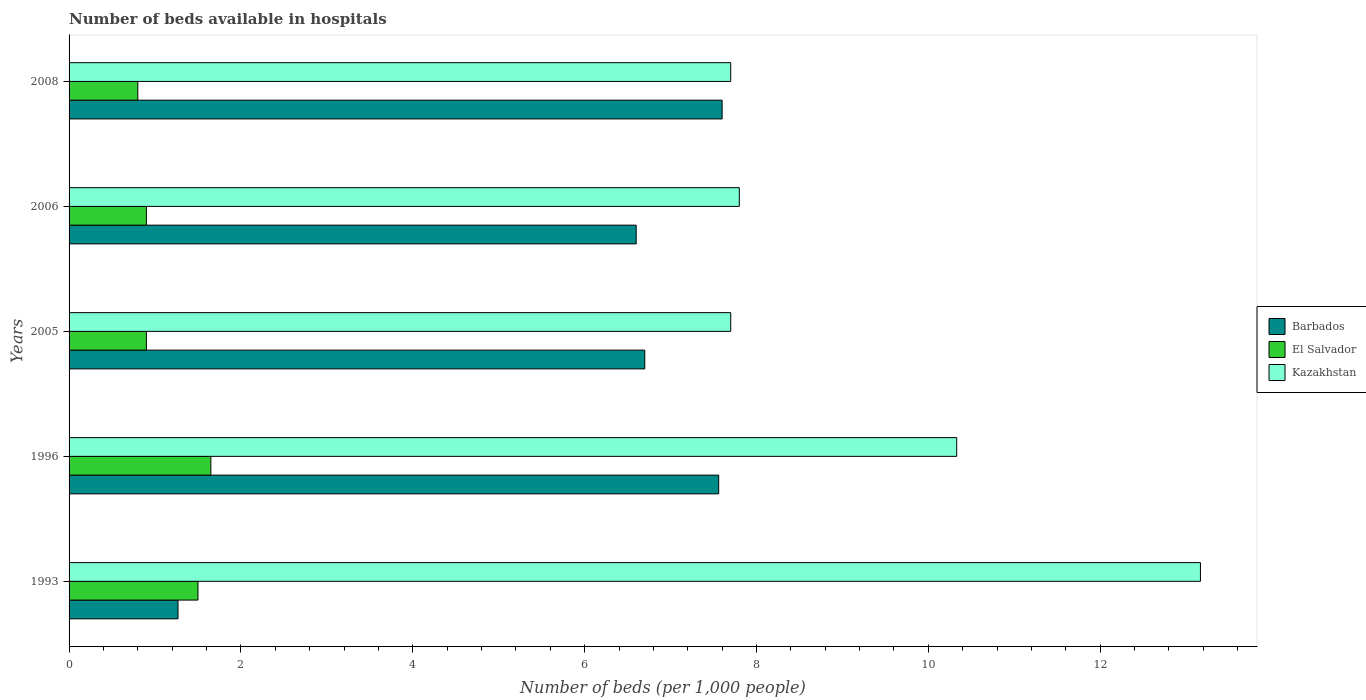How many groups of bars are there?
Give a very brief answer. 5. Are the number of bars per tick equal to the number of legend labels?
Provide a short and direct response. Yes. Are the number of bars on each tick of the Y-axis equal?
Your response must be concise. Yes. What is the label of the 3rd group of bars from the top?
Give a very brief answer. 2005. In how many cases, is the number of bars for a given year not equal to the number of legend labels?
Give a very brief answer. 0. What is the number of beds in the hospiatls of in El Salvador in 1996?
Provide a succinct answer. 1.65. Across all years, what is the maximum number of beds in the hospiatls of in Kazakhstan?
Your response must be concise. 13.17. Across all years, what is the minimum number of beds in the hospiatls of in Barbados?
Offer a very short reply. 1.27. In which year was the number of beds in the hospiatls of in Kazakhstan maximum?
Keep it short and to the point. 1993. What is the total number of beds in the hospiatls of in Kazakhstan in the graph?
Provide a succinct answer. 46.7. What is the difference between the number of beds in the hospiatls of in El Salvador in 1993 and that in 1996?
Your response must be concise. -0.15. What is the average number of beds in the hospiatls of in El Salvador per year?
Make the answer very short. 1.15. In how many years, is the number of beds in the hospiatls of in El Salvador greater than 11.6 ?
Ensure brevity in your answer.  0. What is the ratio of the number of beds in the hospiatls of in El Salvador in 2005 to that in 2006?
Your answer should be very brief. 1. What is the difference between the highest and the second highest number of beds in the hospiatls of in El Salvador?
Offer a terse response. 0.15. What is the difference between the highest and the lowest number of beds in the hospiatls of in El Salvador?
Provide a short and direct response. 0.85. What does the 2nd bar from the top in 2005 represents?
Your answer should be very brief. El Salvador. What does the 3rd bar from the bottom in 1996 represents?
Offer a very short reply. Kazakhstan. How many bars are there?
Offer a very short reply. 15. Are all the bars in the graph horizontal?
Your response must be concise. Yes. Where does the legend appear in the graph?
Your answer should be very brief. Center right. How many legend labels are there?
Your response must be concise. 3. What is the title of the graph?
Your answer should be very brief. Number of beds available in hospitals. Does "Myanmar" appear as one of the legend labels in the graph?
Offer a very short reply. No. What is the label or title of the X-axis?
Provide a short and direct response. Number of beds (per 1,0 people). What is the label or title of the Y-axis?
Offer a terse response. Years. What is the Number of beds (per 1,000 people) in Barbados in 1993?
Offer a very short reply. 1.27. What is the Number of beds (per 1,000 people) of Kazakhstan in 1993?
Offer a terse response. 13.17. What is the Number of beds (per 1,000 people) of Barbados in 1996?
Ensure brevity in your answer.  7.56. What is the Number of beds (per 1,000 people) of El Salvador in 1996?
Your answer should be very brief. 1.65. What is the Number of beds (per 1,000 people) of Kazakhstan in 1996?
Ensure brevity in your answer.  10.33. What is the Number of beds (per 1,000 people) of Barbados in 2005?
Your answer should be very brief. 6.7. What is the Number of beds (per 1,000 people) of El Salvador in 2005?
Ensure brevity in your answer.  0.9. What is the Number of beds (per 1,000 people) of El Salvador in 2006?
Your response must be concise. 0.9. What is the Number of beds (per 1,000 people) of Kazakhstan in 2006?
Your answer should be very brief. 7.8. What is the Number of beds (per 1,000 people) of Barbados in 2008?
Make the answer very short. 7.6. What is the Number of beds (per 1,000 people) of El Salvador in 2008?
Provide a succinct answer. 0.8. What is the Number of beds (per 1,000 people) of Kazakhstan in 2008?
Keep it short and to the point. 7.7. Across all years, what is the maximum Number of beds (per 1,000 people) of Barbados?
Ensure brevity in your answer.  7.6. Across all years, what is the maximum Number of beds (per 1,000 people) of El Salvador?
Give a very brief answer. 1.65. Across all years, what is the maximum Number of beds (per 1,000 people) of Kazakhstan?
Ensure brevity in your answer.  13.17. Across all years, what is the minimum Number of beds (per 1,000 people) of Barbados?
Provide a short and direct response. 1.27. Across all years, what is the minimum Number of beds (per 1,000 people) in Kazakhstan?
Your answer should be very brief. 7.7. What is the total Number of beds (per 1,000 people) in Barbados in the graph?
Provide a succinct answer. 29.73. What is the total Number of beds (per 1,000 people) of El Salvador in the graph?
Provide a short and direct response. 5.75. What is the total Number of beds (per 1,000 people) of Kazakhstan in the graph?
Offer a terse response. 46.7. What is the difference between the Number of beds (per 1,000 people) of Barbados in 1993 and that in 1996?
Your answer should be very brief. -6.29. What is the difference between the Number of beds (per 1,000 people) of El Salvador in 1993 and that in 1996?
Give a very brief answer. -0.15. What is the difference between the Number of beds (per 1,000 people) in Kazakhstan in 1993 and that in 1996?
Your response must be concise. 2.84. What is the difference between the Number of beds (per 1,000 people) of Barbados in 1993 and that in 2005?
Keep it short and to the point. -5.43. What is the difference between the Number of beds (per 1,000 people) in El Salvador in 1993 and that in 2005?
Ensure brevity in your answer.  0.6. What is the difference between the Number of beds (per 1,000 people) of Kazakhstan in 1993 and that in 2005?
Your response must be concise. 5.47. What is the difference between the Number of beds (per 1,000 people) in Barbados in 1993 and that in 2006?
Provide a succinct answer. -5.33. What is the difference between the Number of beds (per 1,000 people) of El Salvador in 1993 and that in 2006?
Provide a short and direct response. 0.6. What is the difference between the Number of beds (per 1,000 people) in Kazakhstan in 1993 and that in 2006?
Provide a succinct answer. 5.37. What is the difference between the Number of beds (per 1,000 people) of Barbados in 1993 and that in 2008?
Make the answer very short. -6.33. What is the difference between the Number of beds (per 1,000 people) in El Salvador in 1993 and that in 2008?
Provide a succinct answer. 0.7. What is the difference between the Number of beds (per 1,000 people) in Kazakhstan in 1993 and that in 2008?
Your answer should be very brief. 5.47. What is the difference between the Number of beds (per 1,000 people) in Barbados in 1996 and that in 2005?
Offer a terse response. 0.86. What is the difference between the Number of beds (per 1,000 people) in Kazakhstan in 1996 and that in 2005?
Provide a succinct answer. 2.63. What is the difference between the Number of beds (per 1,000 people) in Kazakhstan in 1996 and that in 2006?
Give a very brief answer. 2.53. What is the difference between the Number of beds (per 1,000 people) in Barbados in 1996 and that in 2008?
Ensure brevity in your answer.  -0.04. What is the difference between the Number of beds (per 1,000 people) of El Salvador in 1996 and that in 2008?
Your response must be concise. 0.85. What is the difference between the Number of beds (per 1,000 people) of Kazakhstan in 1996 and that in 2008?
Offer a terse response. 2.63. What is the difference between the Number of beds (per 1,000 people) of Barbados in 2005 and that in 2006?
Keep it short and to the point. 0.1. What is the difference between the Number of beds (per 1,000 people) of El Salvador in 2005 and that in 2006?
Your answer should be compact. 0. What is the difference between the Number of beds (per 1,000 people) of Barbados in 1993 and the Number of beds (per 1,000 people) of El Salvador in 1996?
Make the answer very short. -0.38. What is the difference between the Number of beds (per 1,000 people) in Barbados in 1993 and the Number of beds (per 1,000 people) in Kazakhstan in 1996?
Offer a terse response. -9.06. What is the difference between the Number of beds (per 1,000 people) in El Salvador in 1993 and the Number of beds (per 1,000 people) in Kazakhstan in 1996?
Give a very brief answer. -8.83. What is the difference between the Number of beds (per 1,000 people) of Barbados in 1993 and the Number of beds (per 1,000 people) of El Salvador in 2005?
Keep it short and to the point. 0.37. What is the difference between the Number of beds (per 1,000 people) in Barbados in 1993 and the Number of beds (per 1,000 people) in Kazakhstan in 2005?
Offer a terse response. -6.43. What is the difference between the Number of beds (per 1,000 people) of El Salvador in 1993 and the Number of beds (per 1,000 people) of Kazakhstan in 2005?
Provide a succinct answer. -6.2. What is the difference between the Number of beds (per 1,000 people) in Barbados in 1993 and the Number of beds (per 1,000 people) in El Salvador in 2006?
Make the answer very short. 0.37. What is the difference between the Number of beds (per 1,000 people) in Barbados in 1993 and the Number of beds (per 1,000 people) in Kazakhstan in 2006?
Offer a terse response. -6.53. What is the difference between the Number of beds (per 1,000 people) in Barbados in 1993 and the Number of beds (per 1,000 people) in El Salvador in 2008?
Offer a very short reply. 0.47. What is the difference between the Number of beds (per 1,000 people) of Barbados in 1993 and the Number of beds (per 1,000 people) of Kazakhstan in 2008?
Keep it short and to the point. -6.43. What is the difference between the Number of beds (per 1,000 people) of Barbados in 1996 and the Number of beds (per 1,000 people) of El Salvador in 2005?
Give a very brief answer. 6.66. What is the difference between the Number of beds (per 1,000 people) in Barbados in 1996 and the Number of beds (per 1,000 people) in Kazakhstan in 2005?
Make the answer very short. -0.14. What is the difference between the Number of beds (per 1,000 people) of El Salvador in 1996 and the Number of beds (per 1,000 people) of Kazakhstan in 2005?
Ensure brevity in your answer.  -6.05. What is the difference between the Number of beds (per 1,000 people) of Barbados in 1996 and the Number of beds (per 1,000 people) of El Salvador in 2006?
Provide a short and direct response. 6.66. What is the difference between the Number of beds (per 1,000 people) in Barbados in 1996 and the Number of beds (per 1,000 people) in Kazakhstan in 2006?
Give a very brief answer. -0.24. What is the difference between the Number of beds (per 1,000 people) in El Salvador in 1996 and the Number of beds (per 1,000 people) in Kazakhstan in 2006?
Ensure brevity in your answer.  -6.15. What is the difference between the Number of beds (per 1,000 people) in Barbados in 1996 and the Number of beds (per 1,000 people) in El Salvador in 2008?
Your response must be concise. 6.76. What is the difference between the Number of beds (per 1,000 people) in Barbados in 1996 and the Number of beds (per 1,000 people) in Kazakhstan in 2008?
Keep it short and to the point. -0.14. What is the difference between the Number of beds (per 1,000 people) of El Salvador in 1996 and the Number of beds (per 1,000 people) of Kazakhstan in 2008?
Your response must be concise. -6.05. What is the difference between the Number of beds (per 1,000 people) of Barbados in 2005 and the Number of beds (per 1,000 people) of Kazakhstan in 2006?
Provide a succinct answer. -1.1. What is the difference between the Number of beds (per 1,000 people) in Barbados in 2005 and the Number of beds (per 1,000 people) in El Salvador in 2008?
Your answer should be compact. 5.9. What is the difference between the Number of beds (per 1,000 people) in Barbados in 2006 and the Number of beds (per 1,000 people) in El Salvador in 2008?
Offer a terse response. 5.8. What is the difference between the Number of beds (per 1,000 people) of Barbados in 2006 and the Number of beds (per 1,000 people) of Kazakhstan in 2008?
Your answer should be compact. -1.1. What is the difference between the Number of beds (per 1,000 people) of El Salvador in 2006 and the Number of beds (per 1,000 people) of Kazakhstan in 2008?
Offer a very short reply. -6.8. What is the average Number of beds (per 1,000 people) in Barbados per year?
Keep it short and to the point. 5.95. What is the average Number of beds (per 1,000 people) of El Salvador per year?
Ensure brevity in your answer.  1.15. What is the average Number of beds (per 1,000 people) of Kazakhstan per year?
Ensure brevity in your answer.  9.34. In the year 1993, what is the difference between the Number of beds (per 1,000 people) of Barbados and Number of beds (per 1,000 people) of El Salvador?
Give a very brief answer. -0.23. In the year 1993, what is the difference between the Number of beds (per 1,000 people) of Barbados and Number of beds (per 1,000 people) of Kazakhstan?
Make the answer very short. -11.9. In the year 1993, what is the difference between the Number of beds (per 1,000 people) in El Salvador and Number of beds (per 1,000 people) in Kazakhstan?
Your response must be concise. -11.67. In the year 1996, what is the difference between the Number of beds (per 1,000 people) in Barbados and Number of beds (per 1,000 people) in El Salvador?
Your answer should be very brief. 5.91. In the year 1996, what is the difference between the Number of beds (per 1,000 people) of Barbados and Number of beds (per 1,000 people) of Kazakhstan?
Give a very brief answer. -2.77. In the year 1996, what is the difference between the Number of beds (per 1,000 people) of El Salvador and Number of beds (per 1,000 people) of Kazakhstan?
Your answer should be very brief. -8.68. In the year 2005, what is the difference between the Number of beds (per 1,000 people) in El Salvador and Number of beds (per 1,000 people) in Kazakhstan?
Your response must be concise. -6.8. In the year 2006, what is the difference between the Number of beds (per 1,000 people) of Barbados and Number of beds (per 1,000 people) of Kazakhstan?
Make the answer very short. -1.2. In the year 2006, what is the difference between the Number of beds (per 1,000 people) of El Salvador and Number of beds (per 1,000 people) of Kazakhstan?
Offer a terse response. -6.9. In the year 2008, what is the difference between the Number of beds (per 1,000 people) of Barbados and Number of beds (per 1,000 people) of Kazakhstan?
Make the answer very short. -0.1. In the year 2008, what is the difference between the Number of beds (per 1,000 people) in El Salvador and Number of beds (per 1,000 people) in Kazakhstan?
Your answer should be compact. -6.9. What is the ratio of the Number of beds (per 1,000 people) in Barbados in 1993 to that in 1996?
Offer a terse response. 0.17. What is the ratio of the Number of beds (per 1,000 people) in El Salvador in 1993 to that in 1996?
Keep it short and to the point. 0.91. What is the ratio of the Number of beds (per 1,000 people) of Kazakhstan in 1993 to that in 1996?
Keep it short and to the point. 1.27. What is the ratio of the Number of beds (per 1,000 people) of Barbados in 1993 to that in 2005?
Provide a short and direct response. 0.19. What is the ratio of the Number of beds (per 1,000 people) of El Salvador in 1993 to that in 2005?
Your answer should be very brief. 1.67. What is the ratio of the Number of beds (per 1,000 people) in Kazakhstan in 1993 to that in 2005?
Provide a short and direct response. 1.71. What is the ratio of the Number of beds (per 1,000 people) in Barbados in 1993 to that in 2006?
Give a very brief answer. 0.19. What is the ratio of the Number of beds (per 1,000 people) in El Salvador in 1993 to that in 2006?
Keep it short and to the point. 1.67. What is the ratio of the Number of beds (per 1,000 people) of Kazakhstan in 1993 to that in 2006?
Make the answer very short. 1.69. What is the ratio of the Number of beds (per 1,000 people) in Barbados in 1993 to that in 2008?
Provide a succinct answer. 0.17. What is the ratio of the Number of beds (per 1,000 people) in El Salvador in 1993 to that in 2008?
Provide a succinct answer. 1.88. What is the ratio of the Number of beds (per 1,000 people) of Kazakhstan in 1993 to that in 2008?
Your answer should be very brief. 1.71. What is the ratio of the Number of beds (per 1,000 people) in Barbados in 1996 to that in 2005?
Your answer should be compact. 1.13. What is the ratio of the Number of beds (per 1,000 people) in El Salvador in 1996 to that in 2005?
Ensure brevity in your answer.  1.83. What is the ratio of the Number of beds (per 1,000 people) in Kazakhstan in 1996 to that in 2005?
Your response must be concise. 1.34. What is the ratio of the Number of beds (per 1,000 people) in Barbados in 1996 to that in 2006?
Your response must be concise. 1.15. What is the ratio of the Number of beds (per 1,000 people) in El Salvador in 1996 to that in 2006?
Your answer should be very brief. 1.83. What is the ratio of the Number of beds (per 1,000 people) in Kazakhstan in 1996 to that in 2006?
Offer a terse response. 1.32. What is the ratio of the Number of beds (per 1,000 people) in Barbados in 1996 to that in 2008?
Your answer should be very brief. 0.99. What is the ratio of the Number of beds (per 1,000 people) in El Salvador in 1996 to that in 2008?
Ensure brevity in your answer.  2.06. What is the ratio of the Number of beds (per 1,000 people) in Kazakhstan in 1996 to that in 2008?
Provide a short and direct response. 1.34. What is the ratio of the Number of beds (per 1,000 people) in Barbados in 2005 to that in 2006?
Your answer should be compact. 1.02. What is the ratio of the Number of beds (per 1,000 people) in El Salvador in 2005 to that in 2006?
Provide a short and direct response. 1. What is the ratio of the Number of beds (per 1,000 people) of Kazakhstan in 2005 to that in 2006?
Your answer should be compact. 0.99. What is the ratio of the Number of beds (per 1,000 people) of Barbados in 2005 to that in 2008?
Make the answer very short. 0.88. What is the ratio of the Number of beds (per 1,000 people) in El Salvador in 2005 to that in 2008?
Offer a terse response. 1.12. What is the ratio of the Number of beds (per 1,000 people) of Kazakhstan in 2005 to that in 2008?
Give a very brief answer. 1. What is the ratio of the Number of beds (per 1,000 people) of Barbados in 2006 to that in 2008?
Your response must be concise. 0.87. What is the ratio of the Number of beds (per 1,000 people) of El Salvador in 2006 to that in 2008?
Make the answer very short. 1.12. What is the difference between the highest and the second highest Number of beds (per 1,000 people) in El Salvador?
Your answer should be compact. 0.15. What is the difference between the highest and the second highest Number of beds (per 1,000 people) of Kazakhstan?
Keep it short and to the point. 2.84. What is the difference between the highest and the lowest Number of beds (per 1,000 people) of Barbados?
Provide a succinct answer. 6.33. What is the difference between the highest and the lowest Number of beds (per 1,000 people) of Kazakhstan?
Ensure brevity in your answer.  5.47. 